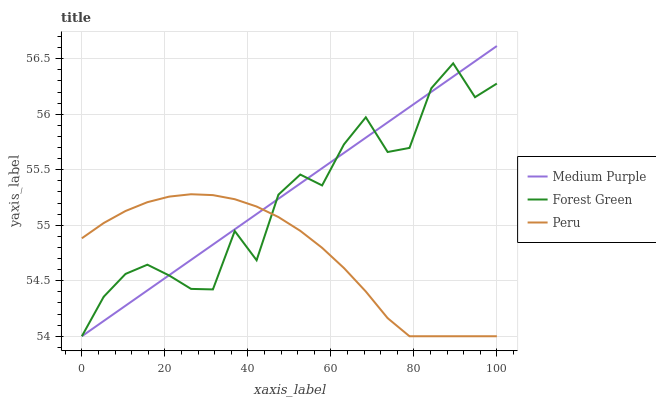Does Peru have the minimum area under the curve?
Answer yes or no. Yes. Does Medium Purple have the maximum area under the curve?
Answer yes or no. Yes. Does Forest Green have the minimum area under the curve?
Answer yes or no. No. Does Forest Green have the maximum area under the curve?
Answer yes or no. No. Is Medium Purple the smoothest?
Answer yes or no. Yes. Is Forest Green the roughest?
Answer yes or no. Yes. Is Peru the smoothest?
Answer yes or no. No. Is Peru the roughest?
Answer yes or no. No. Does Medium Purple have the highest value?
Answer yes or no. Yes. Does Forest Green have the highest value?
Answer yes or no. No. Does Forest Green intersect Medium Purple?
Answer yes or no. Yes. Is Forest Green less than Medium Purple?
Answer yes or no. No. Is Forest Green greater than Medium Purple?
Answer yes or no. No. 